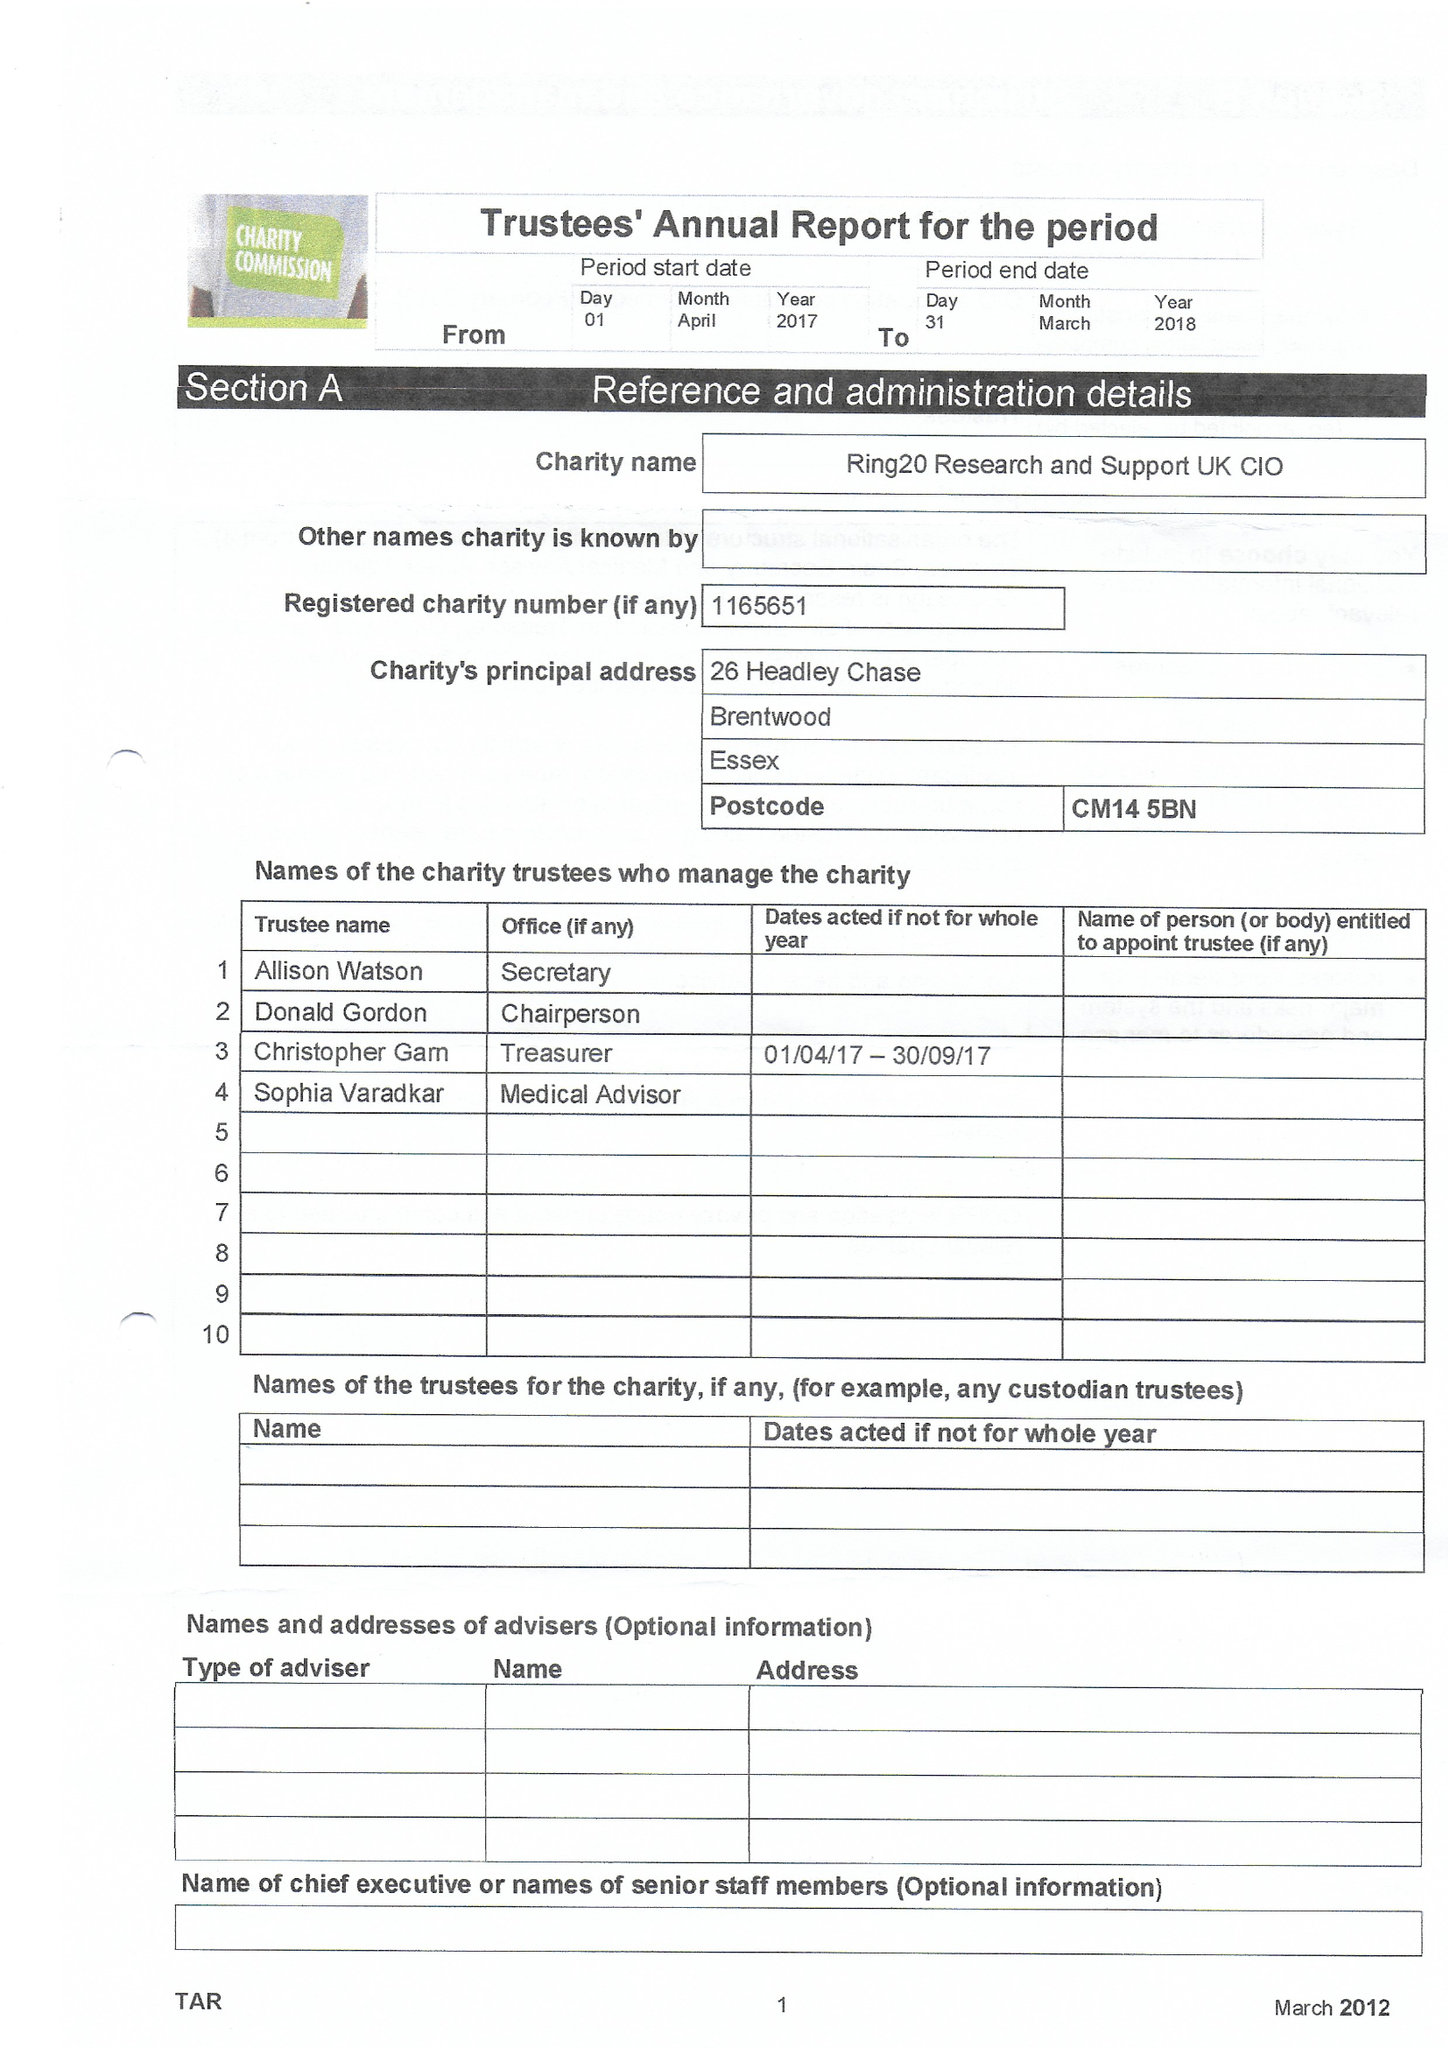What is the value for the report_date?
Answer the question using a single word or phrase. 2018-03-31 